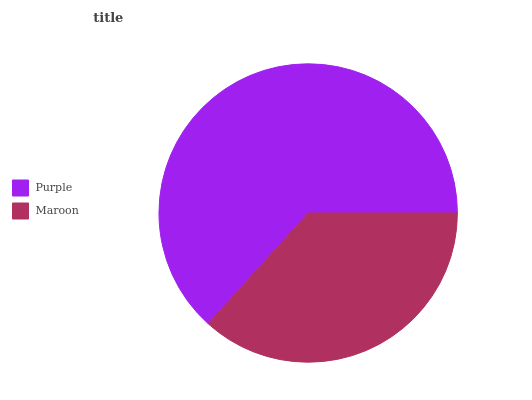Is Maroon the minimum?
Answer yes or no. Yes. Is Purple the maximum?
Answer yes or no. Yes. Is Maroon the maximum?
Answer yes or no. No. Is Purple greater than Maroon?
Answer yes or no. Yes. Is Maroon less than Purple?
Answer yes or no. Yes. Is Maroon greater than Purple?
Answer yes or no. No. Is Purple less than Maroon?
Answer yes or no. No. Is Purple the high median?
Answer yes or no. Yes. Is Maroon the low median?
Answer yes or no. Yes. Is Maroon the high median?
Answer yes or no. No. Is Purple the low median?
Answer yes or no. No. 